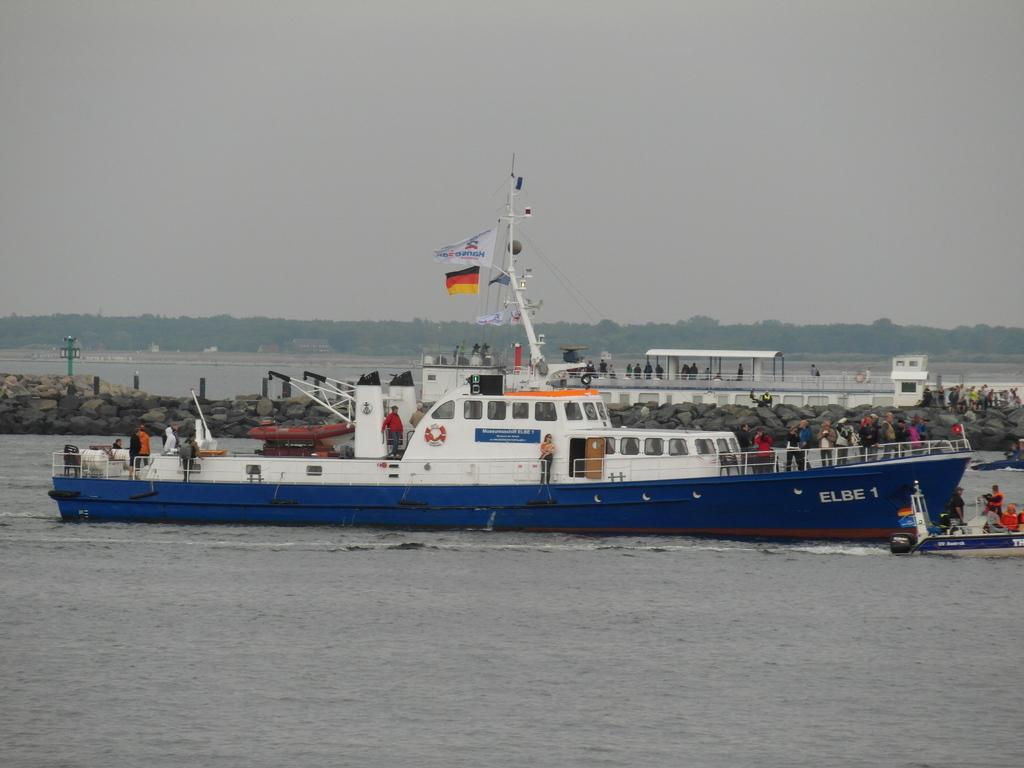Please provide a concise description of this image. In this image we can see a ship. There are people standing. In the background of the image there are trees, sky, There is a boat, stones. At the bottom of the image there is water. 